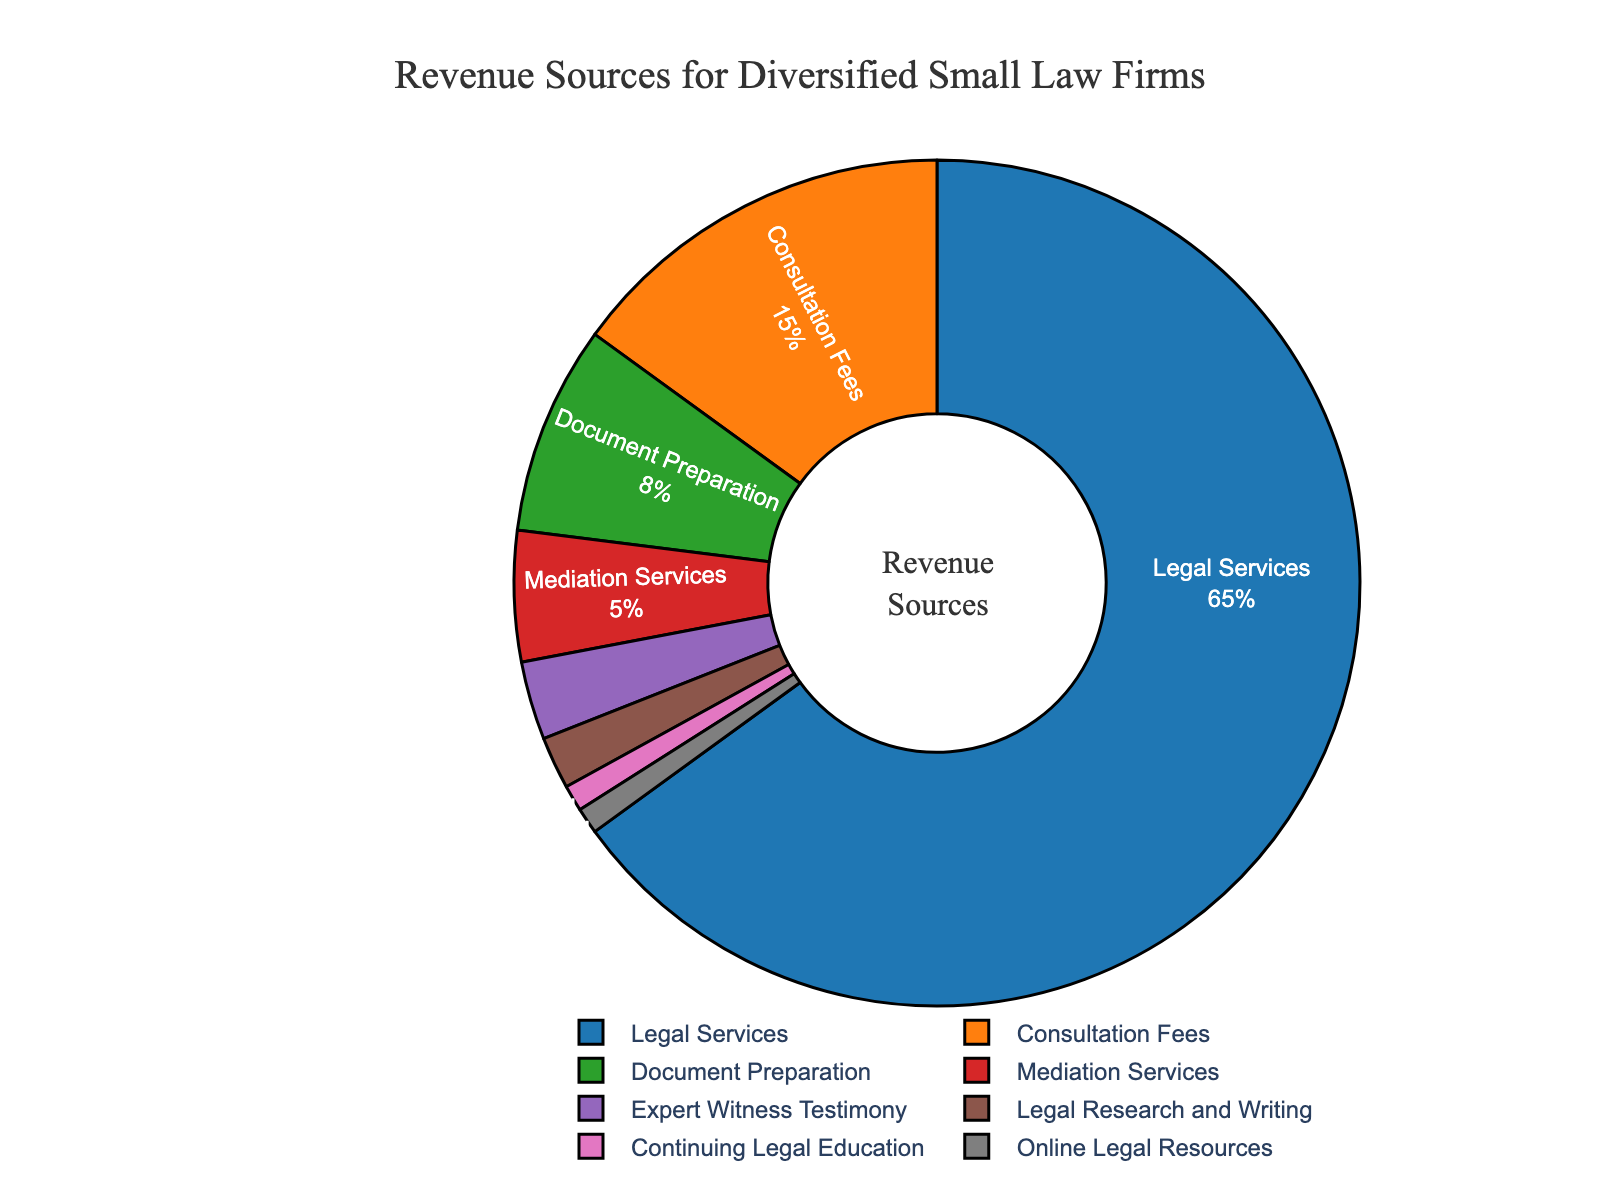What percentage of revenue comes from Legal Services? The figure shows that Legal Services constitutes 65% of the revenue.
Answer: 65% Which revenue source contributes the lowest percentage? The figure shows that Continuing Legal Education and Online Legal Resources are the smallest slices, both contributing 1% each.
Answer: Continuing Legal Education and Online Legal Resources What is the combined percentage of revenue from Legal Services and Consultation Fees? Legal Services contribute 65%, and Consultation Fees contribute 15%. Their combined percentage is 65% + 15% = 80%.
Answer: 80% Are Document Preparation and Mediation Services together greater than Consultation Fees? Document Preparation is 8% and Mediation Services is 5%. Together, they add up to 8% + 5% = 13%, which is less than 15% for Consultation Fees.
Answer: No How does the percentage of revenue from Expert Witness Testimony compare to Mediation Services? Expert Witness Testimony contributes 3%, whereas Mediation Services contribute 5%. So, Expert Witness Testimony is less than Mediation Services.
Answer: Less Which category has the fourth largest revenue percentage? The categories are listed as follows in descending order of percentage: Legal Services (65%), Consultation Fees (15%), Document Preparation (8%), and then Mediation Services (5%).
Answer: Mediation Services What is the total percentage of revenue from non-service-based sources? Non-service-based sources include Document Preparation (8%) and Online Legal Resources (1%). Total is 8% + 1% = 9%.
Answer: 9% How many times larger is the revenue percentage from Legal Services compared to Legal Research and Writing? Legal Services is 65%, and Legal Research and Writing is 2%. So, 65% / 2% = 32.5 times.
Answer: 32.5 times What's the difference between the percentage of revenue from Legal Services and the combined percentage of Document Preparation and Expert Witness Testimony? Legal Services is 65%, and the combined percentage of Document Preparation (8%) and Expert Witness Testimony (3%) is 8% + 3% = 11%. The difference is 65% - 11% = 54%.
Answer: 54% Which revenue source has the dark blue section in the pie chart? The dark blue section represents the largest portion, which corresponds to Legal Services.
Answer: Legal Services 